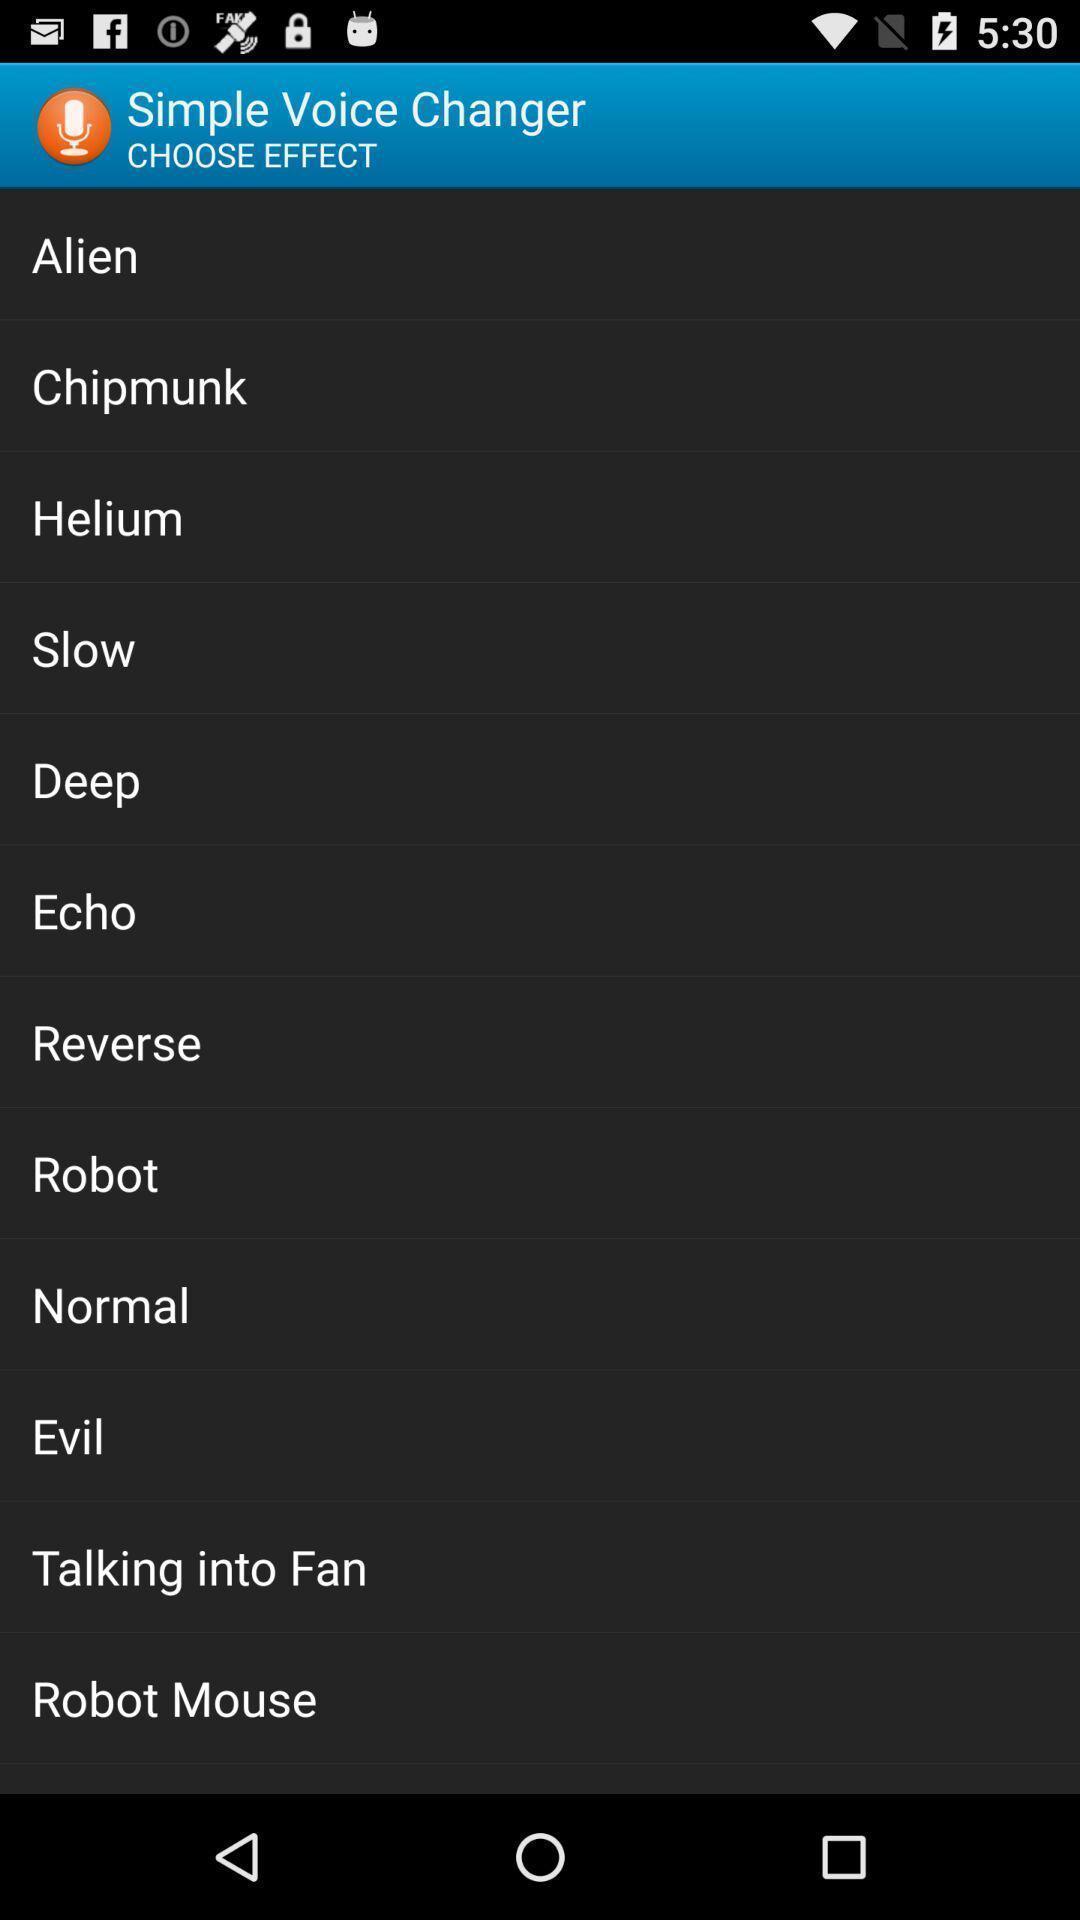Summarize the main components in this picture. Screen displaying multiple sound names. 